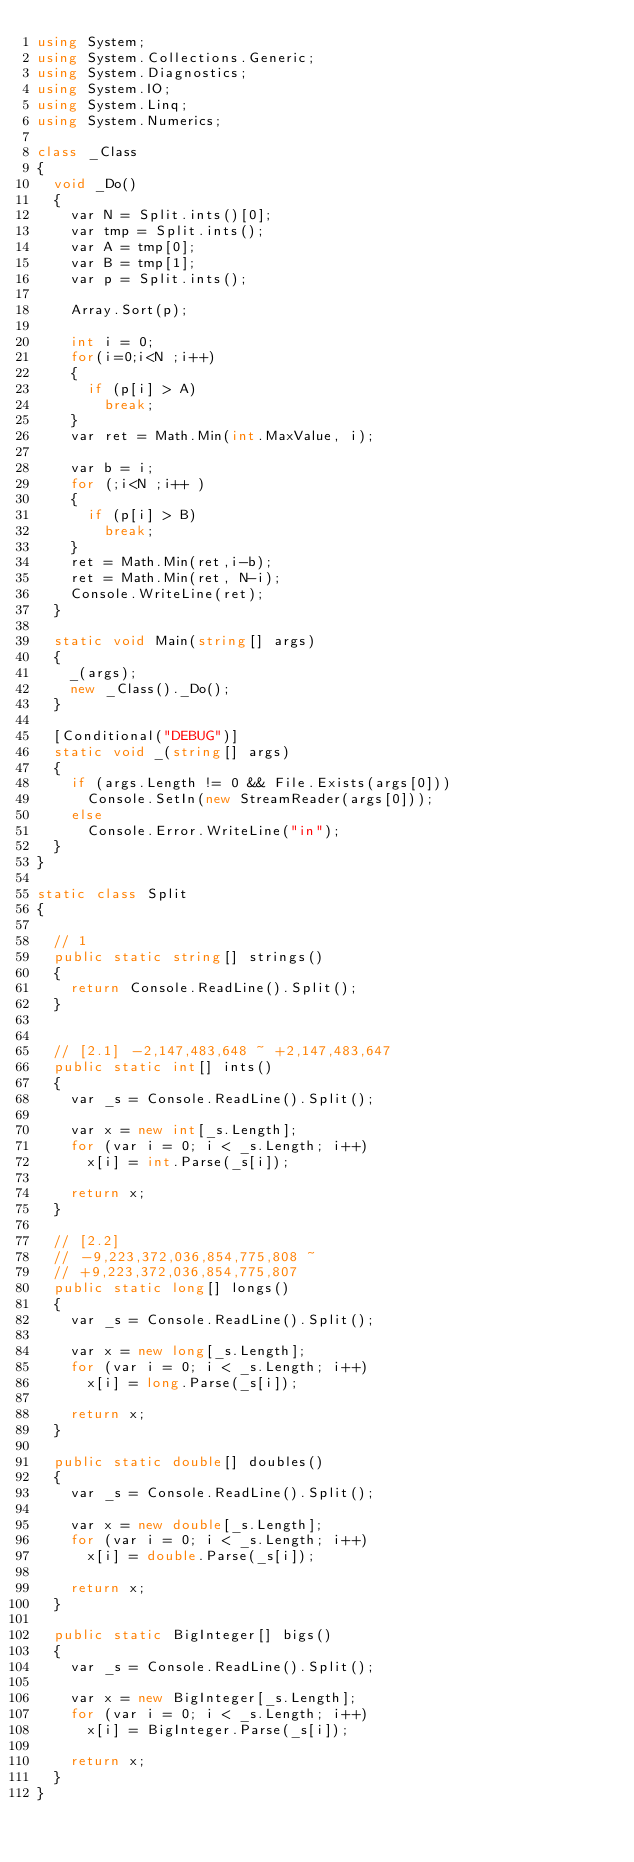Convert code to text. <code><loc_0><loc_0><loc_500><loc_500><_C#_>using System;
using System.Collections.Generic;
using System.Diagnostics;
using System.IO;
using System.Linq;
using System.Numerics;

class _Class
{
  void _Do()
  {
    var N = Split.ints()[0];
    var tmp = Split.ints();
    var A = tmp[0];
    var B = tmp[1];
    var p = Split.ints();

    Array.Sort(p);

    int i = 0;
    for(i=0;i<N ;i++)
    {
      if (p[i] > A)
        break;
    }
    var ret = Math.Min(int.MaxValue, i);

    var b = i;
    for (;i<N ;i++ )
    {
      if (p[i] > B)
        break;
    }
    ret = Math.Min(ret,i-b);
    ret = Math.Min(ret, N-i);
    Console.WriteLine(ret);
  }

  static void Main(string[] args)
  {
    _(args);
    new _Class()._Do();
  }

  [Conditional("DEBUG")]
  static void _(string[] args)
  {
    if (args.Length != 0 && File.Exists(args[0]))
      Console.SetIn(new StreamReader(args[0]));
    else
      Console.Error.WriteLine("in");
  }
}

static class Split
{ 

  // 1
  public static string[] strings()
  {
    return Console.ReadLine().Split();
  }


  // [2.1] -2,147,483,648 ~ +2,147,483,647
  public static int[] ints()
  {
    var _s = Console.ReadLine().Split();

    var x = new int[_s.Length];
    for (var i = 0; i < _s.Length; i++)
      x[i] = int.Parse(_s[i]);

    return x;
  }

  // [2.2] 
  // -9,223,372,036,854,775,808 ~ 
  // +9,223,372,036,854,775,807
  public static long[] longs()
  {
    var _s = Console.ReadLine().Split();

    var x = new long[_s.Length];
    for (var i = 0; i < _s.Length; i++)
      x[i] = long.Parse(_s[i]);

    return x;
  }

  public static double[] doubles()
  {
    var _s = Console.ReadLine().Split();

    var x = new double[_s.Length];
    for (var i = 0; i < _s.Length; i++)
      x[i] = double.Parse(_s[i]);

    return x;
  }

  public static BigInteger[] bigs()
  {
    var _s = Console.ReadLine().Split();

    var x = new BigInteger[_s.Length];
    for (var i = 0; i < _s.Length; i++)
      x[i] = BigInteger.Parse(_s[i]);

    return x;
  }
}







</code> 